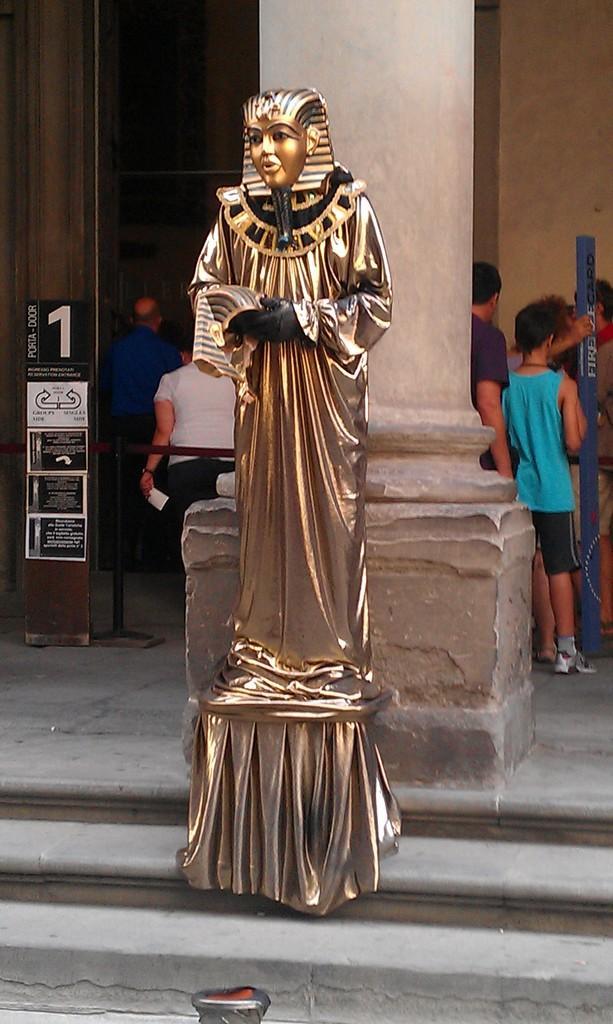Could you give a brief overview of what you see in this image? In this image we can see a statue, behind the statue we can see a pillar, there are few people standing and also we can see a poster with text, in the background it looks like a building. 